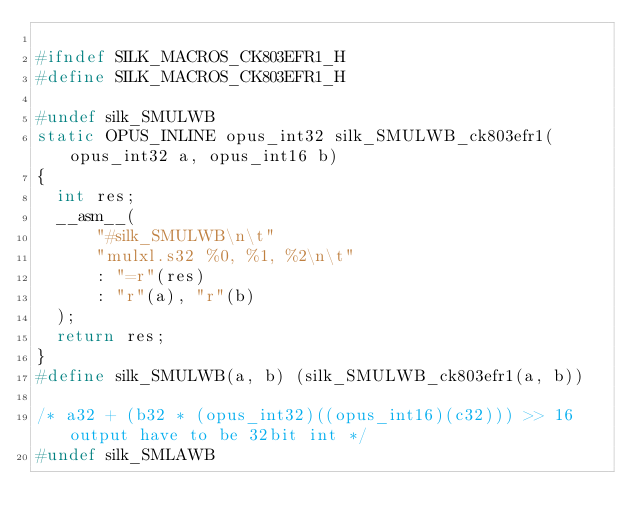<code> <loc_0><loc_0><loc_500><loc_500><_C_>
#ifndef SILK_MACROS_CK803EFR1_H
#define SILK_MACROS_CK803EFR1_H

#undef silk_SMULWB
static OPUS_INLINE opus_int32 silk_SMULWB_ck803efr1(opus_int32 a, opus_int16 b)
{
  int res;
  __asm__(
      "#silk_SMULWB\n\t"
      "mulxl.s32 %0, %1, %2\n\t"
      : "=r"(res)
      : "r"(a), "r"(b)
  );
  return res;
}
#define silk_SMULWB(a, b) (silk_SMULWB_ck803efr1(a, b))

/* a32 + (b32 * (opus_int32)((opus_int16)(c32))) >> 16 output have to be 32bit int */
#undef silk_SMLAWB</code> 